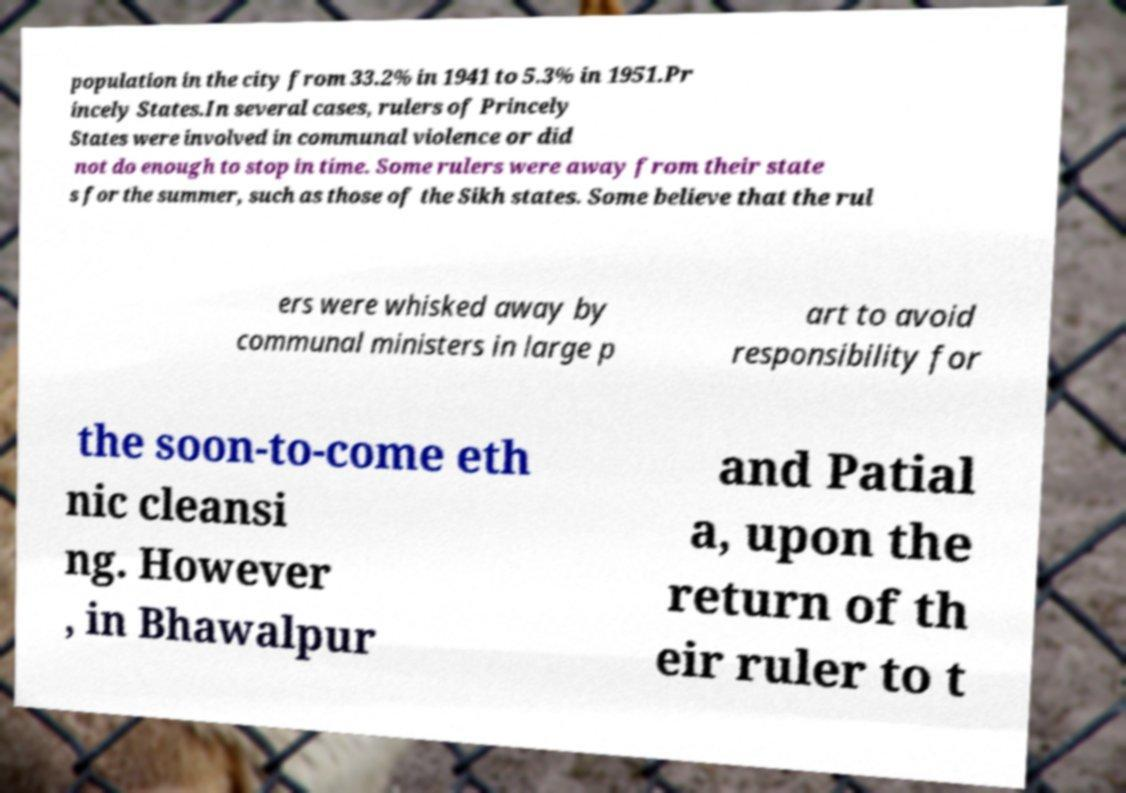Please identify and transcribe the text found in this image. population in the city from 33.2% in 1941 to 5.3% in 1951.Pr incely States.In several cases, rulers of Princely States were involved in communal violence or did not do enough to stop in time. Some rulers were away from their state s for the summer, such as those of the Sikh states. Some believe that the rul ers were whisked away by communal ministers in large p art to avoid responsibility for the soon-to-come eth nic cleansi ng. However , in Bhawalpur and Patial a, upon the return of th eir ruler to t 